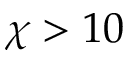Convert formula to latex. <formula><loc_0><loc_0><loc_500><loc_500>\chi > 1 0</formula> 